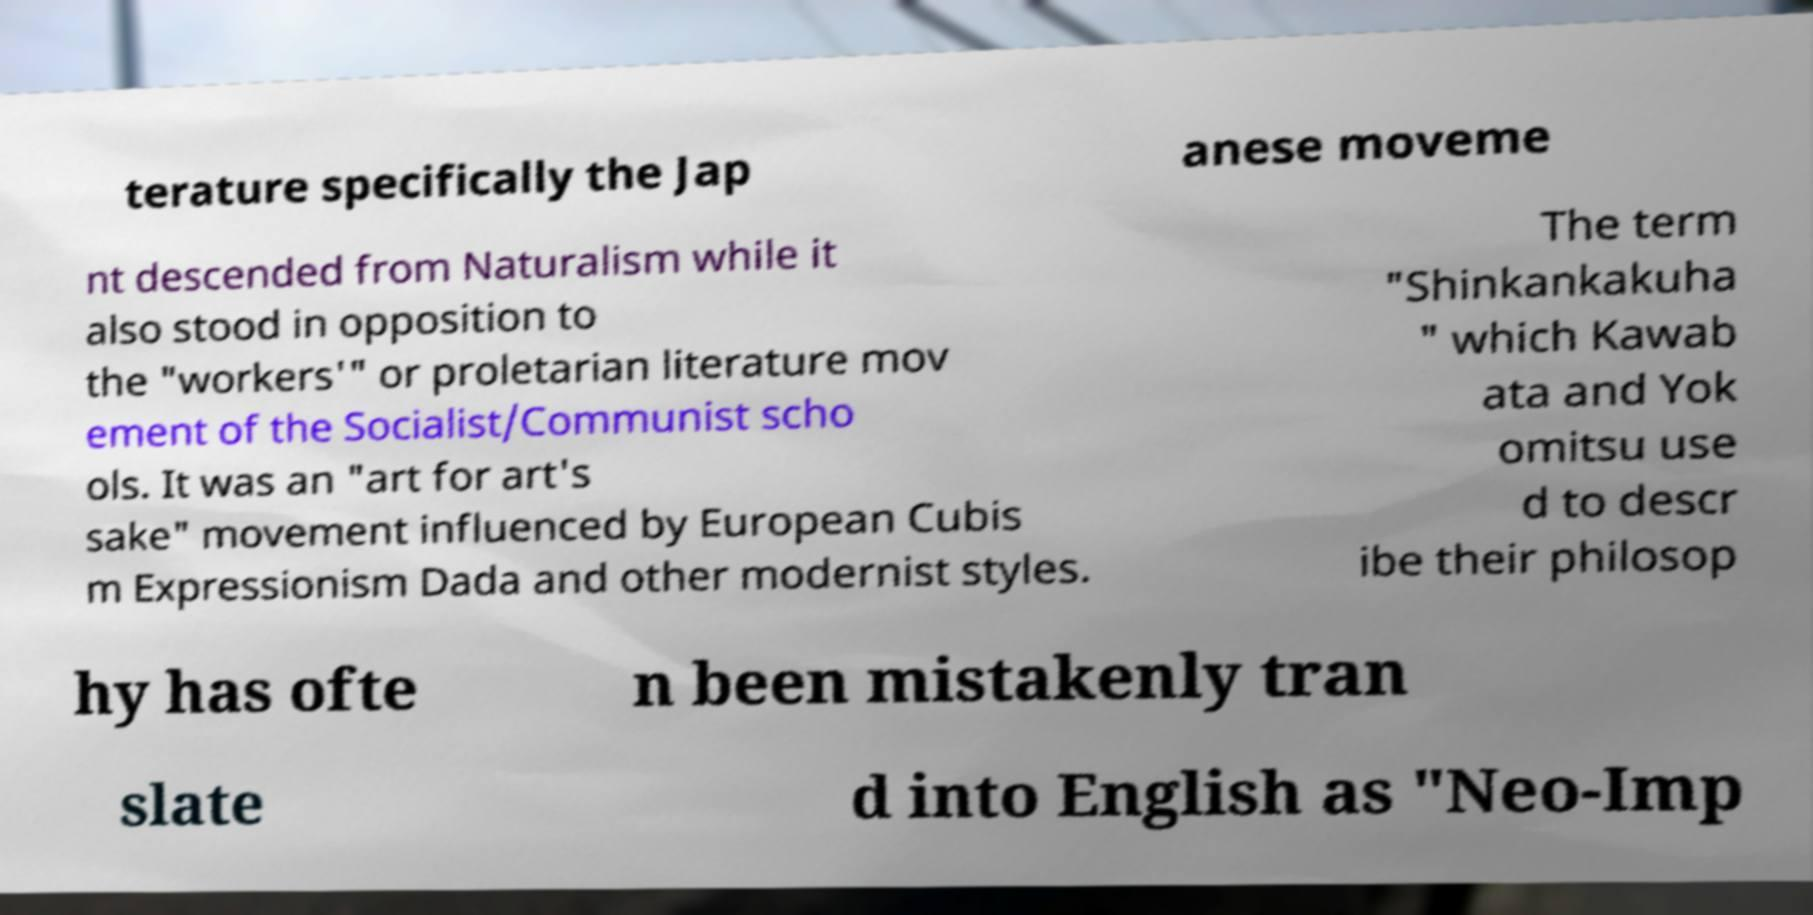For documentation purposes, I need the text within this image transcribed. Could you provide that? terature specifically the Jap anese moveme nt descended from Naturalism while it also stood in opposition to the "workers'" or proletarian literature mov ement of the Socialist/Communist scho ols. It was an "art for art's sake" movement influenced by European Cubis m Expressionism Dada and other modernist styles. The term "Shinkankakuha " which Kawab ata and Yok omitsu use d to descr ibe their philosop hy has ofte n been mistakenly tran slate d into English as "Neo-Imp 